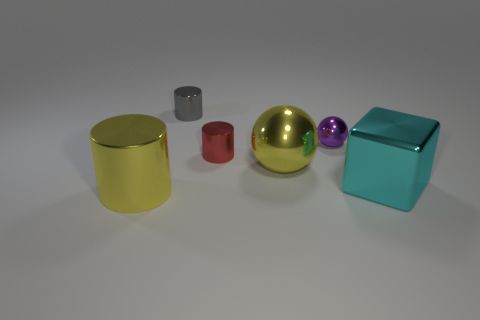Add 2 purple metal balls. How many objects exist? 8 Subtract all balls. How many objects are left? 4 Add 2 large cyan shiny things. How many large cyan shiny things exist? 3 Subtract 0 red blocks. How many objects are left? 6 Subtract all large shiny objects. Subtract all red matte cylinders. How many objects are left? 3 Add 5 large yellow things. How many large yellow things are left? 7 